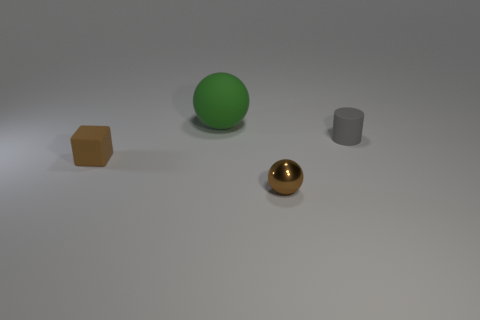What color is the tiny rubber cylinder?
Your response must be concise. Gray. What number of things are metal balls or rubber balls?
Provide a succinct answer. 2. Is there a tiny brown shiny thing of the same shape as the green rubber object?
Keep it short and to the point. Yes. There is a object behind the cylinder; is it the same color as the shiny ball?
Your answer should be compact. No. There is a brown object that is on the right side of the object that is to the left of the large green matte sphere; what is its shape?
Make the answer very short. Sphere. Are there any objects of the same size as the cube?
Your response must be concise. Yes. Is the number of tiny brown cubes less than the number of big gray matte cylinders?
Offer a terse response. No. What shape is the tiny matte object to the right of the brown object in front of the tiny matte object to the left of the big matte sphere?
Ensure brevity in your answer.  Cylinder. What number of things are either balls in front of the small gray cylinder or tiny objects on the left side of the small cylinder?
Keep it short and to the point. 2. There is a large green thing; are there any brown metal objects on the left side of it?
Offer a terse response. No. 